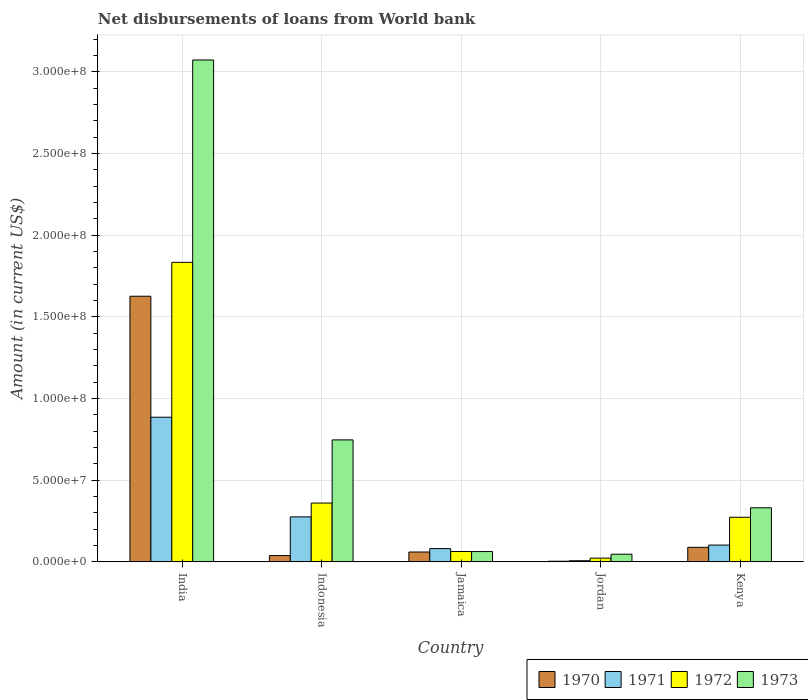How many different coloured bars are there?
Provide a short and direct response. 4. Are the number of bars on each tick of the X-axis equal?
Your answer should be very brief. Yes. How many bars are there on the 4th tick from the right?
Your answer should be compact. 4. What is the label of the 5th group of bars from the left?
Your answer should be compact. Kenya. What is the amount of loan disbursed from World Bank in 1973 in Kenya?
Offer a terse response. 3.31e+07. Across all countries, what is the maximum amount of loan disbursed from World Bank in 1971?
Ensure brevity in your answer.  8.86e+07. Across all countries, what is the minimum amount of loan disbursed from World Bank in 1971?
Offer a very short reply. 6.99e+05. In which country was the amount of loan disbursed from World Bank in 1971 minimum?
Your answer should be compact. Jordan. What is the total amount of loan disbursed from World Bank in 1970 in the graph?
Your response must be concise. 1.82e+08. What is the difference between the amount of loan disbursed from World Bank in 1972 in India and that in Indonesia?
Make the answer very short. 1.47e+08. What is the difference between the amount of loan disbursed from World Bank in 1972 in India and the amount of loan disbursed from World Bank in 1973 in Jordan?
Offer a very short reply. 1.79e+08. What is the average amount of loan disbursed from World Bank in 1972 per country?
Your answer should be compact. 5.11e+07. What is the difference between the amount of loan disbursed from World Bank of/in 1973 and amount of loan disbursed from World Bank of/in 1970 in India?
Offer a very short reply. 1.45e+08. In how many countries, is the amount of loan disbursed from World Bank in 1970 greater than 140000000 US$?
Give a very brief answer. 1. What is the ratio of the amount of loan disbursed from World Bank in 1970 in India to that in Jamaica?
Offer a very short reply. 26.92. What is the difference between the highest and the second highest amount of loan disbursed from World Bank in 1971?
Give a very brief answer. 6.10e+07. What is the difference between the highest and the lowest amount of loan disbursed from World Bank in 1972?
Give a very brief answer. 1.81e+08. What does the 2nd bar from the left in Jamaica represents?
Offer a terse response. 1971. What does the 2nd bar from the right in Jordan represents?
Make the answer very short. 1972. Is it the case that in every country, the sum of the amount of loan disbursed from World Bank in 1971 and amount of loan disbursed from World Bank in 1970 is greater than the amount of loan disbursed from World Bank in 1973?
Your answer should be very brief. No. Are the values on the major ticks of Y-axis written in scientific E-notation?
Offer a very short reply. Yes. Does the graph contain any zero values?
Offer a terse response. No. What is the title of the graph?
Provide a short and direct response. Net disbursements of loans from World bank. Does "1974" appear as one of the legend labels in the graph?
Keep it short and to the point. No. What is the label or title of the X-axis?
Offer a very short reply. Country. What is the Amount (in current US$) in 1970 in India?
Your answer should be compact. 1.63e+08. What is the Amount (in current US$) of 1971 in India?
Make the answer very short. 8.86e+07. What is the Amount (in current US$) of 1972 in India?
Make the answer very short. 1.83e+08. What is the Amount (in current US$) of 1973 in India?
Offer a very short reply. 3.07e+08. What is the Amount (in current US$) in 1970 in Indonesia?
Provide a succinct answer. 3.86e+06. What is the Amount (in current US$) of 1971 in Indonesia?
Your answer should be very brief. 2.76e+07. What is the Amount (in current US$) in 1972 in Indonesia?
Ensure brevity in your answer.  3.60e+07. What is the Amount (in current US$) of 1973 in Indonesia?
Your answer should be very brief. 7.47e+07. What is the Amount (in current US$) in 1970 in Jamaica?
Make the answer very short. 6.04e+06. What is the Amount (in current US$) of 1971 in Jamaica?
Offer a terse response. 8.12e+06. What is the Amount (in current US$) in 1972 in Jamaica?
Make the answer very short. 6.35e+06. What is the Amount (in current US$) of 1973 in Jamaica?
Make the answer very short. 6.32e+06. What is the Amount (in current US$) in 1970 in Jordan?
Provide a short and direct response. 3.99e+05. What is the Amount (in current US$) of 1971 in Jordan?
Ensure brevity in your answer.  6.99e+05. What is the Amount (in current US$) in 1972 in Jordan?
Make the answer very short. 2.30e+06. What is the Amount (in current US$) in 1973 in Jordan?
Make the answer very short. 4.69e+06. What is the Amount (in current US$) of 1970 in Kenya?
Give a very brief answer. 8.91e+06. What is the Amount (in current US$) in 1971 in Kenya?
Ensure brevity in your answer.  1.03e+07. What is the Amount (in current US$) in 1972 in Kenya?
Provide a succinct answer. 2.73e+07. What is the Amount (in current US$) in 1973 in Kenya?
Offer a very short reply. 3.31e+07. Across all countries, what is the maximum Amount (in current US$) of 1970?
Provide a short and direct response. 1.63e+08. Across all countries, what is the maximum Amount (in current US$) of 1971?
Give a very brief answer. 8.86e+07. Across all countries, what is the maximum Amount (in current US$) in 1972?
Offer a very short reply. 1.83e+08. Across all countries, what is the maximum Amount (in current US$) of 1973?
Keep it short and to the point. 3.07e+08. Across all countries, what is the minimum Amount (in current US$) in 1970?
Your response must be concise. 3.99e+05. Across all countries, what is the minimum Amount (in current US$) in 1971?
Give a very brief answer. 6.99e+05. Across all countries, what is the minimum Amount (in current US$) in 1972?
Provide a succinct answer. 2.30e+06. Across all countries, what is the minimum Amount (in current US$) of 1973?
Provide a short and direct response. 4.69e+06. What is the total Amount (in current US$) of 1970 in the graph?
Keep it short and to the point. 1.82e+08. What is the total Amount (in current US$) of 1971 in the graph?
Provide a succinct answer. 1.35e+08. What is the total Amount (in current US$) of 1972 in the graph?
Your response must be concise. 2.55e+08. What is the total Amount (in current US$) in 1973 in the graph?
Your answer should be compact. 4.26e+08. What is the difference between the Amount (in current US$) of 1970 in India and that in Indonesia?
Your answer should be compact. 1.59e+08. What is the difference between the Amount (in current US$) of 1971 in India and that in Indonesia?
Your answer should be very brief. 6.10e+07. What is the difference between the Amount (in current US$) of 1972 in India and that in Indonesia?
Offer a terse response. 1.47e+08. What is the difference between the Amount (in current US$) in 1973 in India and that in Indonesia?
Keep it short and to the point. 2.33e+08. What is the difference between the Amount (in current US$) of 1970 in India and that in Jamaica?
Give a very brief answer. 1.57e+08. What is the difference between the Amount (in current US$) in 1971 in India and that in Jamaica?
Ensure brevity in your answer.  8.04e+07. What is the difference between the Amount (in current US$) of 1972 in India and that in Jamaica?
Give a very brief answer. 1.77e+08. What is the difference between the Amount (in current US$) in 1973 in India and that in Jamaica?
Offer a terse response. 3.01e+08. What is the difference between the Amount (in current US$) in 1970 in India and that in Jordan?
Offer a terse response. 1.62e+08. What is the difference between the Amount (in current US$) in 1971 in India and that in Jordan?
Your answer should be very brief. 8.79e+07. What is the difference between the Amount (in current US$) of 1972 in India and that in Jordan?
Your answer should be compact. 1.81e+08. What is the difference between the Amount (in current US$) of 1973 in India and that in Jordan?
Ensure brevity in your answer.  3.03e+08. What is the difference between the Amount (in current US$) in 1970 in India and that in Kenya?
Offer a very short reply. 1.54e+08. What is the difference between the Amount (in current US$) in 1971 in India and that in Kenya?
Your response must be concise. 7.83e+07. What is the difference between the Amount (in current US$) in 1972 in India and that in Kenya?
Your answer should be compact. 1.56e+08. What is the difference between the Amount (in current US$) in 1973 in India and that in Kenya?
Offer a very short reply. 2.74e+08. What is the difference between the Amount (in current US$) of 1970 in Indonesia and that in Jamaica?
Make the answer very short. -2.18e+06. What is the difference between the Amount (in current US$) of 1971 in Indonesia and that in Jamaica?
Keep it short and to the point. 1.94e+07. What is the difference between the Amount (in current US$) in 1972 in Indonesia and that in Jamaica?
Offer a very short reply. 2.97e+07. What is the difference between the Amount (in current US$) of 1973 in Indonesia and that in Jamaica?
Your response must be concise. 6.84e+07. What is the difference between the Amount (in current US$) of 1970 in Indonesia and that in Jordan?
Offer a very short reply. 3.46e+06. What is the difference between the Amount (in current US$) in 1971 in Indonesia and that in Jordan?
Your response must be concise. 2.69e+07. What is the difference between the Amount (in current US$) in 1972 in Indonesia and that in Jordan?
Provide a succinct answer. 3.37e+07. What is the difference between the Amount (in current US$) of 1973 in Indonesia and that in Jordan?
Your answer should be very brief. 7.00e+07. What is the difference between the Amount (in current US$) in 1970 in Indonesia and that in Kenya?
Your response must be concise. -5.05e+06. What is the difference between the Amount (in current US$) of 1971 in Indonesia and that in Kenya?
Give a very brief answer. 1.73e+07. What is the difference between the Amount (in current US$) of 1972 in Indonesia and that in Kenya?
Keep it short and to the point. 8.70e+06. What is the difference between the Amount (in current US$) of 1973 in Indonesia and that in Kenya?
Your answer should be compact. 4.16e+07. What is the difference between the Amount (in current US$) in 1970 in Jamaica and that in Jordan?
Your answer should be very brief. 5.64e+06. What is the difference between the Amount (in current US$) in 1971 in Jamaica and that in Jordan?
Your response must be concise. 7.43e+06. What is the difference between the Amount (in current US$) in 1972 in Jamaica and that in Jordan?
Your answer should be very brief. 4.05e+06. What is the difference between the Amount (in current US$) in 1973 in Jamaica and that in Jordan?
Provide a short and direct response. 1.63e+06. What is the difference between the Amount (in current US$) in 1970 in Jamaica and that in Kenya?
Provide a succinct answer. -2.87e+06. What is the difference between the Amount (in current US$) of 1971 in Jamaica and that in Kenya?
Your answer should be very brief. -2.16e+06. What is the difference between the Amount (in current US$) of 1972 in Jamaica and that in Kenya?
Offer a very short reply. -2.10e+07. What is the difference between the Amount (in current US$) in 1973 in Jamaica and that in Kenya?
Your answer should be very brief. -2.68e+07. What is the difference between the Amount (in current US$) of 1970 in Jordan and that in Kenya?
Your response must be concise. -8.51e+06. What is the difference between the Amount (in current US$) of 1971 in Jordan and that in Kenya?
Provide a short and direct response. -9.59e+06. What is the difference between the Amount (in current US$) of 1972 in Jordan and that in Kenya?
Ensure brevity in your answer.  -2.50e+07. What is the difference between the Amount (in current US$) of 1973 in Jordan and that in Kenya?
Your answer should be very brief. -2.84e+07. What is the difference between the Amount (in current US$) in 1970 in India and the Amount (in current US$) in 1971 in Indonesia?
Provide a short and direct response. 1.35e+08. What is the difference between the Amount (in current US$) in 1970 in India and the Amount (in current US$) in 1972 in Indonesia?
Provide a succinct answer. 1.27e+08. What is the difference between the Amount (in current US$) in 1970 in India and the Amount (in current US$) in 1973 in Indonesia?
Offer a terse response. 8.80e+07. What is the difference between the Amount (in current US$) of 1971 in India and the Amount (in current US$) of 1972 in Indonesia?
Your answer should be very brief. 5.26e+07. What is the difference between the Amount (in current US$) of 1971 in India and the Amount (in current US$) of 1973 in Indonesia?
Your answer should be very brief. 1.39e+07. What is the difference between the Amount (in current US$) in 1972 in India and the Amount (in current US$) in 1973 in Indonesia?
Make the answer very short. 1.09e+08. What is the difference between the Amount (in current US$) of 1970 in India and the Amount (in current US$) of 1971 in Jamaica?
Offer a very short reply. 1.55e+08. What is the difference between the Amount (in current US$) of 1970 in India and the Amount (in current US$) of 1972 in Jamaica?
Provide a succinct answer. 1.56e+08. What is the difference between the Amount (in current US$) of 1970 in India and the Amount (in current US$) of 1973 in Jamaica?
Offer a terse response. 1.56e+08. What is the difference between the Amount (in current US$) of 1971 in India and the Amount (in current US$) of 1972 in Jamaica?
Provide a short and direct response. 8.22e+07. What is the difference between the Amount (in current US$) of 1971 in India and the Amount (in current US$) of 1973 in Jamaica?
Keep it short and to the point. 8.22e+07. What is the difference between the Amount (in current US$) in 1972 in India and the Amount (in current US$) in 1973 in Jamaica?
Ensure brevity in your answer.  1.77e+08. What is the difference between the Amount (in current US$) in 1970 in India and the Amount (in current US$) in 1971 in Jordan?
Your answer should be compact. 1.62e+08. What is the difference between the Amount (in current US$) in 1970 in India and the Amount (in current US$) in 1972 in Jordan?
Your answer should be compact. 1.60e+08. What is the difference between the Amount (in current US$) of 1970 in India and the Amount (in current US$) of 1973 in Jordan?
Ensure brevity in your answer.  1.58e+08. What is the difference between the Amount (in current US$) in 1971 in India and the Amount (in current US$) in 1972 in Jordan?
Your answer should be very brief. 8.63e+07. What is the difference between the Amount (in current US$) in 1971 in India and the Amount (in current US$) in 1973 in Jordan?
Provide a succinct answer. 8.39e+07. What is the difference between the Amount (in current US$) in 1972 in India and the Amount (in current US$) in 1973 in Jordan?
Your answer should be compact. 1.79e+08. What is the difference between the Amount (in current US$) of 1970 in India and the Amount (in current US$) of 1971 in Kenya?
Give a very brief answer. 1.52e+08. What is the difference between the Amount (in current US$) of 1970 in India and the Amount (in current US$) of 1972 in Kenya?
Provide a succinct answer. 1.35e+08. What is the difference between the Amount (in current US$) in 1970 in India and the Amount (in current US$) in 1973 in Kenya?
Ensure brevity in your answer.  1.30e+08. What is the difference between the Amount (in current US$) of 1971 in India and the Amount (in current US$) of 1972 in Kenya?
Offer a terse response. 6.12e+07. What is the difference between the Amount (in current US$) of 1971 in India and the Amount (in current US$) of 1973 in Kenya?
Provide a succinct answer. 5.54e+07. What is the difference between the Amount (in current US$) of 1972 in India and the Amount (in current US$) of 1973 in Kenya?
Provide a succinct answer. 1.50e+08. What is the difference between the Amount (in current US$) of 1970 in Indonesia and the Amount (in current US$) of 1971 in Jamaica?
Provide a succinct answer. -4.27e+06. What is the difference between the Amount (in current US$) of 1970 in Indonesia and the Amount (in current US$) of 1972 in Jamaica?
Your answer should be compact. -2.49e+06. What is the difference between the Amount (in current US$) in 1970 in Indonesia and the Amount (in current US$) in 1973 in Jamaica?
Offer a very short reply. -2.46e+06. What is the difference between the Amount (in current US$) in 1971 in Indonesia and the Amount (in current US$) in 1972 in Jamaica?
Offer a very short reply. 2.12e+07. What is the difference between the Amount (in current US$) of 1971 in Indonesia and the Amount (in current US$) of 1973 in Jamaica?
Your answer should be very brief. 2.12e+07. What is the difference between the Amount (in current US$) of 1972 in Indonesia and the Amount (in current US$) of 1973 in Jamaica?
Your answer should be compact. 2.97e+07. What is the difference between the Amount (in current US$) in 1970 in Indonesia and the Amount (in current US$) in 1971 in Jordan?
Ensure brevity in your answer.  3.16e+06. What is the difference between the Amount (in current US$) of 1970 in Indonesia and the Amount (in current US$) of 1972 in Jordan?
Provide a short and direct response. 1.56e+06. What is the difference between the Amount (in current US$) in 1970 in Indonesia and the Amount (in current US$) in 1973 in Jordan?
Your answer should be compact. -8.32e+05. What is the difference between the Amount (in current US$) in 1971 in Indonesia and the Amount (in current US$) in 1972 in Jordan?
Your answer should be compact. 2.53e+07. What is the difference between the Amount (in current US$) of 1971 in Indonesia and the Amount (in current US$) of 1973 in Jordan?
Offer a very short reply. 2.29e+07. What is the difference between the Amount (in current US$) in 1972 in Indonesia and the Amount (in current US$) in 1973 in Jordan?
Keep it short and to the point. 3.13e+07. What is the difference between the Amount (in current US$) in 1970 in Indonesia and the Amount (in current US$) in 1971 in Kenya?
Your answer should be compact. -6.43e+06. What is the difference between the Amount (in current US$) in 1970 in Indonesia and the Amount (in current US$) in 1972 in Kenya?
Make the answer very short. -2.34e+07. What is the difference between the Amount (in current US$) of 1970 in Indonesia and the Amount (in current US$) of 1973 in Kenya?
Your answer should be compact. -2.92e+07. What is the difference between the Amount (in current US$) of 1971 in Indonesia and the Amount (in current US$) of 1972 in Kenya?
Keep it short and to the point. 2.45e+05. What is the difference between the Amount (in current US$) of 1971 in Indonesia and the Amount (in current US$) of 1973 in Kenya?
Ensure brevity in your answer.  -5.56e+06. What is the difference between the Amount (in current US$) in 1972 in Indonesia and the Amount (in current US$) in 1973 in Kenya?
Ensure brevity in your answer.  2.90e+06. What is the difference between the Amount (in current US$) in 1970 in Jamaica and the Amount (in current US$) in 1971 in Jordan?
Your answer should be very brief. 5.34e+06. What is the difference between the Amount (in current US$) in 1970 in Jamaica and the Amount (in current US$) in 1972 in Jordan?
Ensure brevity in your answer.  3.74e+06. What is the difference between the Amount (in current US$) in 1970 in Jamaica and the Amount (in current US$) in 1973 in Jordan?
Your answer should be compact. 1.35e+06. What is the difference between the Amount (in current US$) in 1971 in Jamaica and the Amount (in current US$) in 1972 in Jordan?
Offer a terse response. 5.83e+06. What is the difference between the Amount (in current US$) of 1971 in Jamaica and the Amount (in current US$) of 1973 in Jordan?
Make the answer very short. 3.43e+06. What is the difference between the Amount (in current US$) of 1972 in Jamaica and the Amount (in current US$) of 1973 in Jordan?
Your answer should be very brief. 1.66e+06. What is the difference between the Amount (in current US$) in 1970 in Jamaica and the Amount (in current US$) in 1971 in Kenya?
Your answer should be compact. -4.25e+06. What is the difference between the Amount (in current US$) of 1970 in Jamaica and the Amount (in current US$) of 1972 in Kenya?
Provide a short and direct response. -2.13e+07. What is the difference between the Amount (in current US$) of 1970 in Jamaica and the Amount (in current US$) of 1973 in Kenya?
Your response must be concise. -2.71e+07. What is the difference between the Amount (in current US$) of 1971 in Jamaica and the Amount (in current US$) of 1972 in Kenya?
Ensure brevity in your answer.  -1.92e+07. What is the difference between the Amount (in current US$) of 1971 in Jamaica and the Amount (in current US$) of 1973 in Kenya?
Provide a short and direct response. -2.50e+07. What is the difference between the Amount (in current US$) in 1972 in Jamaica and the Amount (in current US$) in 1973 in Kenya?
Provide a succinct answer. -2.68e+07. What is the difference between the Amount (in current US$) in 1970 in Jordan and the Amount (in current US$) in 1971 in Kenya?
Your answer should be compact. -9.89e+06. What is the difference between the Amount (in current US$) of 1970 in Jordan and the Amount (in current US$) of 1972 in Kenya?
Offer a very short reply. -2.69e+07. What is the difference between the Amount (in current US$) of 1970 in Jordan and the Amount (in current US$) of 1973 in Kenya?
Keep it short and to the point. -3.27e+07. What is the difference between the Amount (in current US$) in 1971 in Jordan and the Amount (in current US$) in 1972 in Kenya?
Your response must be concise. -2.66e+07. What is the difference between the Amount (in current US$) of 1971 in Jordan and the Amount (in current US$) of 1973 in Kenya?
Your answer should be compact. -3.24e+07. What is the difference between the Amount (in current US$) of 1972 in Jordan and the Amount (in current US$) of 1973 in Kenya?
Keep it short and to the point. -3.08e+07. What is the average Amount (in current US$) in 1970 per country?
Give a very brief answer. 3.64e+07. What is the average Amount (in current US$) in 1971 per country?
Offer a very short reply. 2.70e+07. What is the average Amount (in current US$) of 1972 per country?
Your response must be concise. 5.11e+07. What is the average Amount (in current US$) in 1973 per country?
Make the answer very short. 8.52e+07. What is the difference between the Amount (in current US$) of 1970 and Amount (in current US$) of 1971 in India?
Give a very brief answer. 7.41e+07. What is the difference between the Amount (in current US$) in 1970 and Amount (in current US$) in 1972 in India?
Your answer should be compact. -2.07e+07. What is the difference between the Amount (in current US$) of 1970 and Amount (in current US$) of 1973 in India?
Provide a short and direct response. -1.45e+08. What is the difference between the Amount (in current US$) in 1971 and Amount (in current US$) in 1972 in India?
Your answer should be very brief. -9.48e+07. What is the difference between the Amount (in current US$) of 1971 and Amount (in current US$) of 1973 in India?
Offer a terse response. -2.19e+08. What is the difference between the Amount (in current US$) of 1972 and Amount (in current US$) of 1973 in India?
Your answer should be compact. -1.24e+08. What is the difference between the Amount (in current US$) of 1970 and Amount (in current US$) of 1971 in Indonesia?
Provide a succinct answer. -2.37e+07. What is the difference between the Amount (in current US$) of 1970 and Amount (in current US$) of 1972 in Indonesia?
Your answer should be very brief. -3.21e+07. What is the difference between the Amount (in current US$) of 1970 and Amount (in current US$) of 1973 in Indonesia?
Make the answer very short. -7.08e+07. What is the difference between the Amount (in current US$) in 1971 and Amount (in current US$) in 1972 in Indonesia?
Your answer should be very brief. -8.45e+06. What is the difference between the Amount (in current US$) of 1971 and Amount (in current US$) of 1973 in Indonesia?
Your response must be concise. -4.71e+07. What is the difference between the Amount (in current US$) of 1972 and Amount (in current US$) of 1973 in Indonesia?
Ensure brevity in your answer.  -3.87e+07. What is the difference between the Amount (in current US$) of 1970 and Amount (in current US$) of 1971 in Jamaica?
Make the answer very short. -2.08e+06. What is the difference between the Amount (in current US$) in 1970 and Amount (in current US$) in 1972 in Jamaica?
Keep it short and to the point. -3.05e+05. What is the difference between the Amount (in current US$) of 1970 and Amount (in current US$) of 1973 in Jamaica?
Your answer should be very brief. -2.79e+05. What is the difference between the Amount (in current US$) of 1971 and Amount (in current US$) of 1972 in Jamaica?
Your answer should be very brief. 1.78e+06. What is the difference between the Amount (in current US$) in 1971 and Amount (in current US$) in 1973 in Jamaica?
Your answer should be compact. 1.80e+06. What is the difference between the Amount (in current US$) in 1972 and Amount (in current US$) in 1973 in Jamaica?
Keep it short and to the point. 2.60e+04. What is the difference between the Amount (in current US$) of 1970 and Amount (in current US$) of 1971 in Jordan?
Your answer should be very brief. -3.00e+05. What is the difference between the Amount (in current US$) in 1970 and Amount (in current US$) in 1972 in Jordan?
Offer a terse response. -1.90e+06. What is the difference between the Amount (in current US$) in 1970 and Amount (in current US$) in 1973 in Jordan?
Ensure brevity in your answer.  -4.29e+06. What is the difference between the Amount (in current US$) of 1971 and Amount (in current US$) of 1972 in Jordan?
Provide a short and direct response. -1.60e+06. What is the difference between the Amount (in current US$) in 1971 and Amount (in current US$) in 1973 in Jordan?
Your answer should be very brief. -3.99e+06. What is the difference between the Amount (in current US$) of 1972 and Amount (in current US$) of 1973 in Jordan?
Provide a succinct answer. -2.39e+06. What is the difference between the Amount (in current US$) of 1970 and Amount (in current US$) of 1971 in Kenya?
Your answer should be very brief. -1.38e+06. What is the difference between the Amount (in current US$) of 1970 and Amount (in current US$) of 1972 in Kenya?
Your answer should be very brief. -1.84e+07. What is the difference between the Amount (in current US$) of 1970 and Amount (in current US$) of 1973 in Kenya?
Keep it short and to the point. -2.42e+07. What is the difference between the Amount (in current US$) in 1971 and Amount (in current US$) in 1972 in Kenya?
Keep it short and to the point. -1.70e+07. What is the difference between the Amount (in current US$) of 1971 and Amount (in current US$) of 1973 in Kenya?
Provide a short and direct response. -2.28e+07. What is the difference between the Amount (in current US$) of 1972 and Amount (in current US$) of 1973 in Kenya?
Give a very brief answer. -5.80e+06. What is the ratio of the Amount (in current US$) in 1970 in India to that in Indonesia?
Your answer should be very brief. 42.14. What is the ratio of the Amount (in current US$) in 1971 in India to that in Indonesia?
Keep it short and to the point. 3.21. What is the ratio of the Amount (in current US$) in 1972 in India to that in Indonesia?
Give a very brief answer. 5.09. What is the ratio of the Amount (in current US$) of 1973 in India to that in Indonesia?
Your response must be concise. 4.11. What is the ratio of the Amount (in current US$) of 1970 in India to that in Jamaica?
Offer a terse response. 26.92. What is the ratio of the Amount (in current US$) of 1971 in India to that in Jamaica?
Give a very brief answer. 10.9. What is the ratio of the Amount (in current US$) in 1972 in India to that in Jamaica?
Provide a succinct answer. 28.89. What is the ratio of the Amount (in current US$) in 1973 in India to that in Jamaica?
Offer a terse response. 48.61. What is the ratio of the Amount (in current US$) of 1970 in India to that in Jordan?
Your response must be concise. 407.6. What is the ratio of the Amount (in current US$) of 1971 in India to that in Jordan?
Your answer should be very brief. 126.69. What is the ratio of the Amount (in current US$) in 1972 in India to that in Jordan?
Offer a terse response. 79.83. What is the ratio of the Amount (in current US$) in 1973 in India to that in Jordan?
Your response must be concise. 65.5. What is the ratio of the Amount (in current US$) of 1970 in India to that in Kenya?
Provide a short and direct response. 18.25. What is the ratio of the Amount (in current US$) in 1971 in India to that in Kenya?
Offer a very short reply. 8.61. What is the ratio of the Amount (in current US$) in 1972 in India to that in Kenya?
Keep it short and to the point. 6.72. What is the ratio of the Amount (in current US$) of 1973 in India to that in Kenya?
Offer a very short reply. 9.28. What is the ratio of the Amount (in current US$) in 1970 in Indonesia to that in Jamaica?
Keep it short and to the point. 0.64. What is the ratio of the Amount (in current US$) of 1971 in Indonesia to that in Jamaica?
Give a very brief answer. 3.39. What is the ratio of the Amount (in current US$) of 1972 in Indonesia to that in Jamaica?
Your answer should be compact. 5.67. What is the ratio of the Amount (in current US$) of 1973 in Indonesia to that in Jamaica?
Provide a short and direct response. 11.81. What is the ratio of the Amount (in current US$) in 1970 in Indonesia to that in Jordan?
Give a very brief answer. 9.67. What is the ratio of the Amount (in current US$) of 1971 in Indonesia to that in Jordan?
Give a very brief answer. 39.42. What is the ratio of the Amount (in current US$) of 1972 in Indonesia to that in Jordan?
Offer a terse response. 15.68. What is the ratio of the Amount (in current US$) in 1973 in Indonesia to that in Jordan?
Your answer should be compact. 15.92. What is the ratio of the Amount (in current US$) of 1970 in Indonesia to that in Kenya?
Provide a short and direct response. 0.43. What is the ratio of the Amount (in current US$) of 1971 in Indonesia to that in Kenya?
Keep it short and to the point. 2.68. What is the ratio of the Amount (in current US$) in 1972 in Indonesia to that in Kenya?
Offer a terse response. 1.32. What is the ratio of the Amount (in current US$) in 1973 in Indonesia to that in Kenya?
Ensure brevity in your answer.  2.26. What is the ratio of the Amount (in current US$) in 1970 in Jamaica to that in Jordan?
Your answer should be compact. 15.14. What is the ratio of the Amount (in current US$) of 1971 in Jamaica to that in Jordan?
Your answer should be compact. 11.62. What is the ratio of the Amount (in current US$) of 1972 in Jamaica to that in Jordan?
Provide a short and direct response. 2.76. What is the ratio of the Amount (in current US$) of 1973 in Jamaica to that in Jordan?
Offer a very short reply. 1.35. What is the ratio of the Amount (in current US$) of 1970 in Jamaica to that in Kenya?
Keep it short and to the point. 0.68. What is the ratio of the Amount (in current US$) in 1971 in Jamaica to that in Kenya?
Your response must be concise. 0.79. What is the ratio of the Amount (in current US$) in 1972 in Jamaica to that in Kenya?
Offer a very short reply. 0.23. What is the ratio of the Amount (in current US$) of 1973 in Jamaica to that in Kenya?
Offer a terse response. 0.19. What is the ratio of the Amount (in current US$) of 1970 in Jordan to that in Kenya?
Make the answer very short. 0.04. What is the ratio of the Amount (in current US$) in 1971 in Jordan to that in Kenya?
Offer a terse response. 0.07. What is the ratio of the Amount (in current US$) of 1972 in Jordan to that in Kenya?
Provide a short and direct response. 0.08. What is the ratio of the Amount (in current US$) in 1973 in Jordan to that in Kenya?
Keep it short and to the point. 0.14. What is the difference between the highest and the second highest Amount (in current US$) of 1970?
Give a very brief answer. 1.54e+08. What is the difference between the highest and the second highest Amount (in current US$) in 1971?
Ensure brevity in your answer.  6.10e+07. What is the difference between the highest and the second highest Amount (in current US$) of 1972?
Your answer should be very brief. 1.47e+08. What is the difference between the highest and the second highest Amount (in current US$) in 1973?
Offer a terse response. 2.33e+08. What is the difference between the highest and the lowest Amount (in current US$) of 1970?
Ensure brevity in your answer.  1.62e+08. What is the difference between the highest and the lowest Amount (in current US$) in 1971?
Offer a very short reply. 8.79e+07. What is the difference between the highest and the lowest Amount (in current US$) of 1972?
Make the answer very short. 1.81e+08. What is the difference between the highest and the lowest Amount (in current US$) of 1973?
Provide a succinct answer. 3.03e+08. 